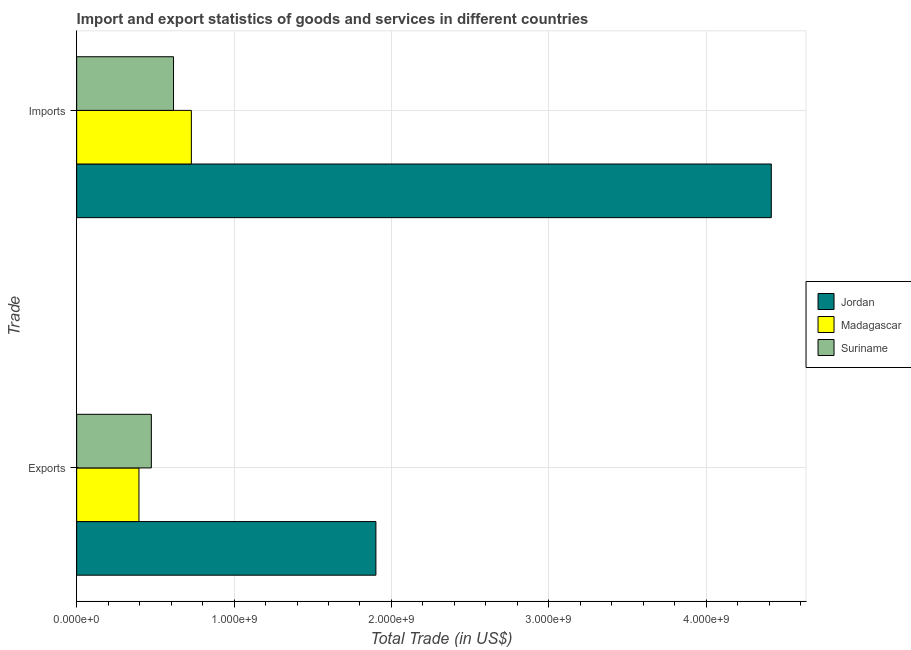How many different coloured bars are there?
Give a very brief answer. 3. How many groups of bars are there?
Offer a very short reply. 2. How many bars are there on the 2nd tick from the top?
Offer a terse response. 3. What is the label of the 2nd group of bars from the top?
Make the answer very short. Exports. What is the imports of goods and services in Suriname?
Your response must be concise. 6.16e+08. Across all countries, what is the maximum export of goods and services?
Offer a very short reply. 1.90e+09. Across all countries, what is the minimum imports of goods and services?
Your answer should be very brief. 6.16e+08. In which country was the imports of goods and services maximum?
Give a very brief answer. Jordan. In which country was the imports of goods and services minimum?
Offer a very short reply. Suriname. What is the total imports of goods and services in the graph?
Offer a very short reply. 5.76e+09. What is the difference between the imports of goods and services in Jordan and that in Suriname?
Your answer should be very brief. 3.80e+09. What is the difference between the imports of goods and services in Jordan and the export of goods and services in Madagascar?
Keep it short and to the point. 4.02e+09. What is the average imports of goods and services per country?
Your answer should be compact. 1.92e+09. What is the difference between the imports of goods and services and export of goods and services in Madagascar?
Your answer should be very brief. 3.33e+08. In how many countries, is the imports of goods and services greater than 2400000000 US$?
Offer a very short reply. 1. What is the ratio of the imports of goods and services in Madagascar to that in Jordan?
Provide a short and direct response. 0.17. In how many countries, is the export of goods and services greater than the average export of goods and services taken over all countries?
Give a very brief answer. 1. What does the 2nd bar from the top in Imports represents?
Give a very brief answer. Madagascar. What does the 2nd bar from the bottom in Exports represents?
Provide a short and direct response. Madagascar. Are all the bars in the graph horizontal?
Your answer should be compact. Yes. How many countries are there in the graph?
Offer a very short reply. 3. What is the difference between two consecutive major ticks on the X-axis?
Your answer should be compact. 1.00e+09. Does the graph contain any zero values?
Keep it short and to the point. No. Does the graph contain grids?
Your answer should be very brief. Yes. What is the title of the graph?
Ensure brevity in your answer.  Import and export statistics of goods and services in different countries. What is the label or title of the X-axis?
Give a very brief answer. Total Trade (in US$). What is the label or title of the Y-axis?
Offer a very short reply. Trade. What is the Total Trade (in US$) in Jordan in Exports?
Your response must be concise. 1.90e+09. What is the Total Trade (in US$) in Madagascar in Exports?
Make the answer very short. 3.96e+08. What is the Total Trade (in US$) of Suriname in Exports?
Ensure brevity in your answer.  4.74e+08. What is the Total Trade (in US$) of Jordan in Imports?
Provide a succinct answer. 4.41e+09. What is the Total Trade (in US$) in Madagascar in Imports?
Provide a short and direct response. 7.29e+08. What is the Total Trade (in US$) of Suriname in Imports?
Provide a succinct answer. 6.16e+08. Across all Trade, what is the maximum Total Trade (in US$) of Jordan?
Ensure brevity in your answer.  4.41e+09. Across all Trade, what is the maximum Total Trade (in US$) of Madagascar?
Your answer should be very brief. 7.29e+08. Across all Trade, what is the maximum Total Trade (in US$) of Suriname?
Offer a very short reply. 6.16e+08. Across all Trade, what is the minimum Total Trade (in US$) in Jordan?
Keep it short and to the point. 1.90e+09. Across all Trade, what is the minimum Total Trade (in US$) of Madagascar?
Offer a very short reply. 3.96e+08. Across all Trade, what is the minimum Total Trade (in US$) in Suriname?
Provide a succinct answer. 4.74e+08. What is the total Total Trade (in US$) in Jordan in the graph?
Offer a terse response. 6.31e+09. What is the total Total Trade (in US$) of Madagascar in the graph?
Your response must be concise. 1.12e+09. What is the total Total Trade (in US$) of Suriname in the graph?
Offer a very short reply. 1.09e+09. What is the difference between the Total Trade (in US$) of Jordan in Exports and that in Imports?
Your response must be concise. -2.51e+09. What is the difference between the Total Trade (in US$) in Madagascar in Exports and that in Imports?
Keep it short and to the point. -3.33e+08. What is the difference between the Total Trade (in US$) of Suriname in Exports and that in Imports?
Provide a short and direct response. -1.41e+08. What is the difference between the Total Trade (in US$) in Jordan in Exports and the Total Trade (in US$) in Madagascar in Imports?
Offer a terse response. 1.17e+09. What is the difference between the Total Trade (in US$) of Jordan in Exports and the Total Trade (in US$) of Suriname in Imports?
Your answer should be very brief. 1.29e+09. What is the difference between the Total Trade (in US$) in Madagascar in Exports and the Total Trade (in US$) in Suriname in Imports?
Offer a terse response. -2.20e+08. What is the average Total Trade (in US$) of Jordan per Trade?
Give a very brief answer. 3.16e+09. What is the average Total Trade (in US$) in Madagascar per Trade?
Provide a short and direct response. 5.62e+08. What is the average Total Trade (in US$) of Suriname per Trade?
Make the answer very short. 5.45e+08. What is the difference between the Total Trade (in US$) of Jordan and Total Trade (in US$) of Madagascar in Exports?
Keep it short and to the point. 1.51e+09. What is the difference between the Total Trade (in US$) of Jordan and Total Trade (in US$) of Suriname in Exports?
Your response must be concise. 1.43e+09. What is the difference between the Total Trade (in US$) of Madagascar and Total Trade (in US$) of Suriname in Exports?
Your response must be concise. -7.87e+07. What is the difference between the Total Trade (in US$) in Jordan and Total Trade (in US$) in Madagascar in Imports?
Provide a short and direct response. 3.68e+09. What is the difference between the Total Trade (in US$) in Jordan and Total Trade (in US$) in Suriname in Imports?
Your answer should be compact. 3.80e+09. What is the difference between the Total Trade (in US$) of Madagascar and Total Trade (in US$) of Suriname in Imports?
Give a very brief answer. 1.13e+08. What is the ratio of the Total Trade (in US$) of Jordan in Exports to that in Imports?
Provide a succinct answer. 0.43. What is the ratio of the Total Trade (in US$) of Madagascar in Exports to that in Imports?
Your response must be concise. 0.54. What is the ratio of the Total Trade (in US$) of Suriname in Exports to that in Imports?
Make the answer very short. 0.77. What is the difference between the highest and the second highest Total Trade (in US$) in Jordan?
Provide a short and direct response. 2.51e+09. What is the difference between the highest and the second highest Total Trade (in US$) in Madagascar?
Offer a terse response. 3.33e+08. What is the difference between the highest and the second highest Total Trade (in US$) in Suriname?
Offer a very short reply. 1.41e+08. What is the difference between the highest and the lowest Total Trade (in US$) in Jordan?
Your answer should be very brief. 2.51e+09. What is the difference between the highest and the lowest Total Trade (in US$) in Madagascar?
Offer a terse response. 3.33e+08. What is the difference between the highest and the lowest Total Trade (in US$) in Suriname?
Give a very brief answer. 1.41e+08. 